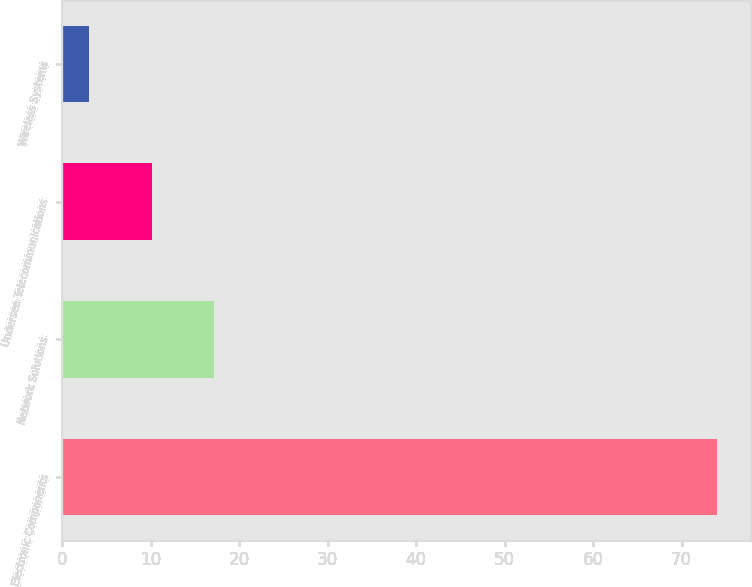Convert chart to OTSL. <chart><loc_0><loc_0><loc_500><loc_500><bar_chart><fcel>Electronic Components<fcel>Network Solutions<fcel>Undersea Telecommunications<fcel>Wireless Systems<nl><fcel>74<fcel>17.2<fcel>10.1<fcel>3<nl></chart> 